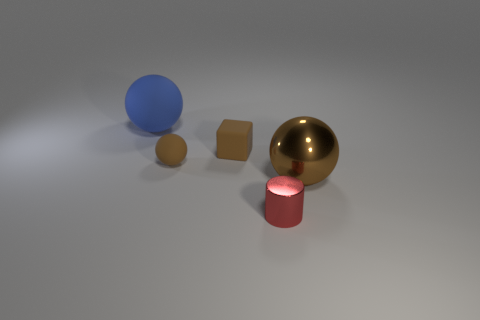Is the size of the blue thing the same as the brown metallic object?
Your answer should be very brief. Yes. What number of things are either large objects that are to the right of the blue sphere or brown objects that are on the right side of the tiny rubber block?
Make the answer very short. 1. There is a metal object in front of the ball on the right side of the red shiny cylinder; how many big blue rubber spheres are in front of it?
Provide a short and direct response. 0. What is the size of the metallic thing on the right side of the tiny cylinder?
Offer a very short reply. Large. How many other blue objects are the same size as the blue matte object?
Keep it short and to the point. 0. Does the blue ball have the same size as the metal object that is right of the tiny cylinder?
Offer a very short reply. Yes. What number of objects are small rubber balls or big blue matte balls?
Provide a succinct answer. 2. How many tiny rubber balls have the same color as the tiny block?
Offer a very short reply. 1. What is the shape of the blue matte object that is the same size as the shiny sphere?
Ensure brevity in your answer.  Sphere. Are there any purple things of the same shape as the big brown metal thing?
Give a very brief answer. No. 